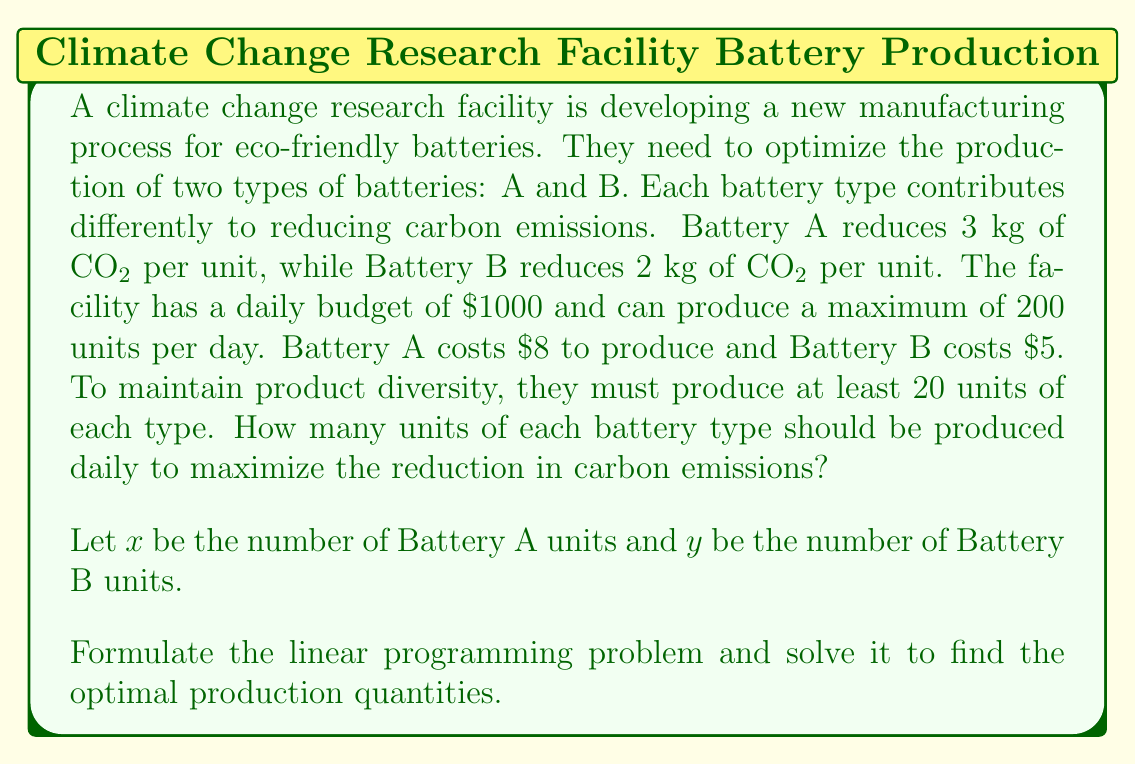Help me with this question. To solve this linear programming problem, we need to follow these steps:

1. Define the objective function
2. Identify the constraints
3. Set up the linear programming model
4. Solve the model using the graphical method or simplex algorithm

Step 1: Define the objective function

We want to maximize the reduction in carbon emissions. Battery A reduces 3 kg of CO2 per unit, and Battery B reduces 2 kg of CO2 per unit.

Objective function: Maximize $Z = 3x + 2y$

Step 2: Identify the constraints

a) Budget constraint: $8x + 5y \leq 1000$
b) Production capacity constraint: $x + y \leq 200$
c) Minimum production for Battery A: $x \geq 20$
d) Minimum production for Battery B: $y \geq 20$
e) Non-negativity constraints: $x \geq 0, y \geq 0$

Step 3: Set up the linear programming model

Maximize $Z = 3x + 2y$
Subject to:
$8x + 5y \leq 1000$
$x + y \leq 200$
$x \geq 20$
$y \geq 20$
$x, y \geq 0$

Step 4: Solve the model

We can solve this problem graphically by plotting the constraints and finding the feasible region. The optimal solution will be at one of the corner points of the feasible region.

The corner points are:
(20, 20), (20, 180), (100, 100), (125, 75), (120, 80)

Evaluating the objective function at each point:
(20, 20): $Z = 3(20) + 2(20) = 100$
(20, 180): $Z = 3(20) + 2(180) = 420$
(100, 100): $Z = 3(100) + 2(100) = 500$
(125, 75): $Z = 3(125) + 2(75) = 525$
(120, 80): $Z = 3(120) + 2(80) = 520$

The maximum value of Z occurs at the point (125, 75).
Answer: The optimal production quantities are 125 units of Battery A and 75 units of Battery B, resulting in a maximum reduction of 525 kg of CO2 emissions per day. 